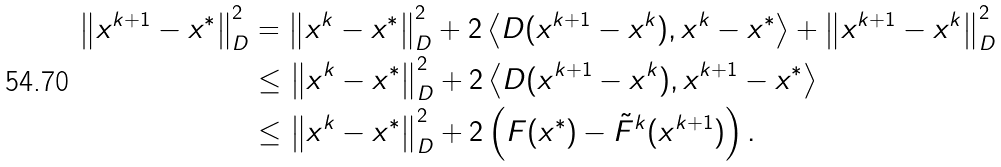Convert formula to latex. <formula><loc_0><loc_0><loc_500><loc_500>\left \| x ^ { k + 1 } - x ^ { * } \right \| _ { D } ^ { 2 } & = \left \| x ^ { k } - x ^ { * } \right \| _ { D } ^ { 2 } + 2 \left \langle D ( x ^ { k + 1 } - x ^ { k } ) , x ^ { k } - x ^ { * } \right \rangle + \left \| x ^ { k + 1 } - x ^ { k } \right \| _ { D } ^ { 2 } \\ & \leq \left \| x ^ { k } - x ^ { * } \right \| _ { D } ^ { 2 } + 2 \left \langle D ( x ^ { k + 1 } - x ^ { k } ) , x ^ { k + 1 } - x ^ { * } \right \rangle \\ & \leq \left \| x ^ { k } - x ^ { * } \right \| _ { D } ^ { 2 } + 2 \left ( F ( x ^ { * } ) - \tilde { F } ^ { k } ( x ^ { k + 1 } ) \right ) .</formula> 